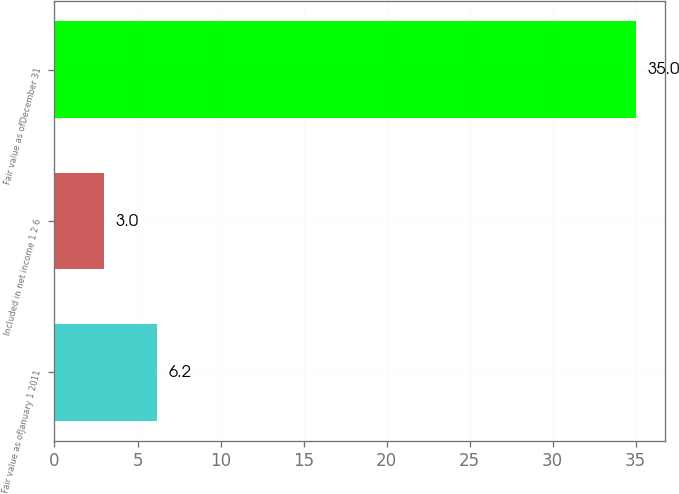Convert chart to OTSL. <chart><loc_0><loc_0><loc_500><loc_500><bar_chart><fcel>Fair value as ofJanuary 1 2011<fcel>Included in net income 1 2 6<fcel>Fair value as ofDecember 31<nl><fcel>6.2<fcel>3<fcel>35<nl></chart> 